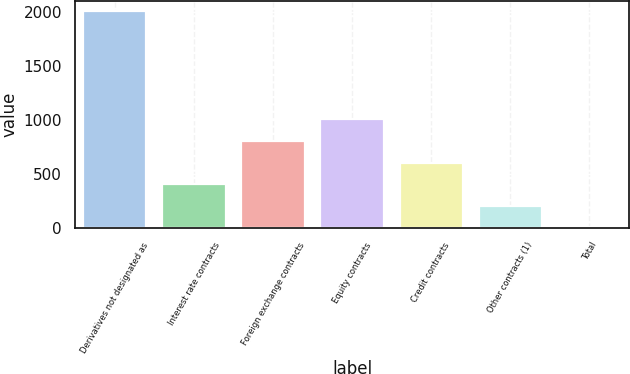Convert chart. <chart><loc_0><loc_0><loc_500><loc_500><bar_chart><fcel>Derivatives not designated as<fcel>Interest rate contracts<fcel>Foreign exchange contracts<fcel>Equity contracts<fcel>Credit contracts<fcel>Other contracts (1)<fcel>Total<nl><fcel>2009<fcel>405.64<fcel>806.48<fcel>1006.9<fcel>606.06<fcel>205.22<fcel>4.8<nl></chart> 